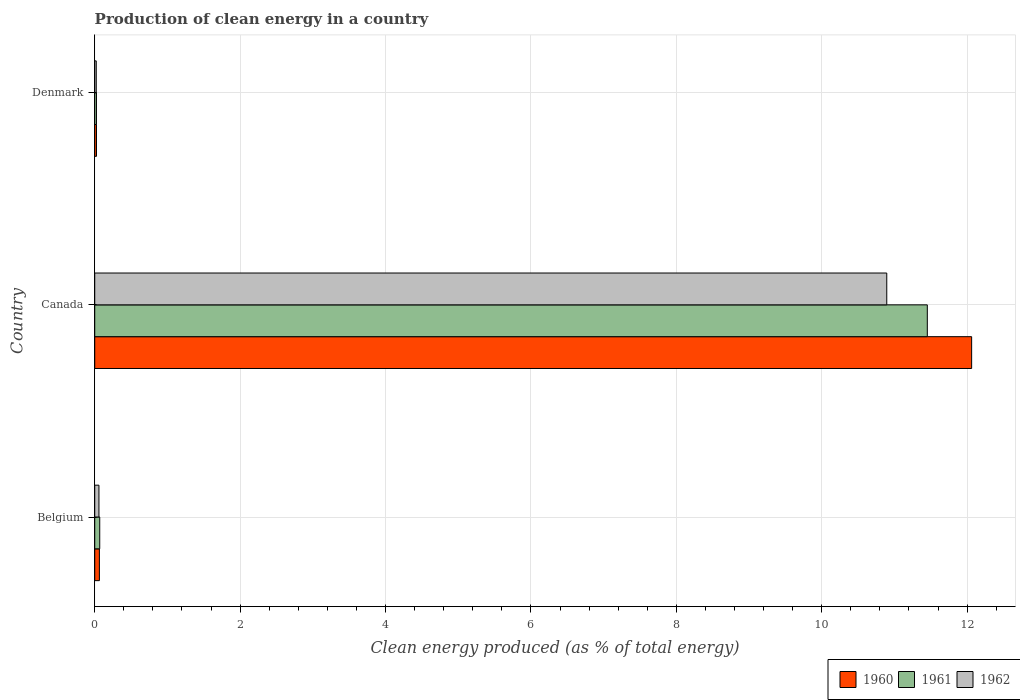Are the number of bars per tick equal to the number of legend labels?
Your response must be concise. Yes. What is the percentage of clean energy produced in 1961 in Belgium?
Your answer should be compact. 0.07. Across all countries, what is the maximum percentage of clean energy produced in 1962?
Make the answer very short. 10.89. Across all countries, what is the minimum percentage of clean energy produced in 1960?
Provide a short and direct response. 0.02. In which country was the percentage of clean energy produced in 1960 maximum?
Ensure brevity in your answer.  Canada. In which country was the percentage of clean energy produced in 1961 minimum?
Your answer should be very brief. Denmark. What is the total percentage of clean energy produced in 1961 in the graph?
Your answer should be very brief. 11.55. What is the difference between the percentage of clean energy produced in 1962 in Belgium and that in Denmark?
Provide a succinct answer. 0.04. What is the difference between the percentage of clean energy produced in 1961 in Denmark and the percentage of clean energy produced in 1960 in Belgium?
Offer a very short reply. -0.04. What is the average percentage of clean energy produced in 1960 per country?
Keep it short and to the point. 4.05. What is the difference between the percentage of clean energy produced in 1962 and percentage of clean energy produced in 1961 in Denmark?
Ensure brevity in your answer.  -0. In how many countries, is the percentage of clean energy produced in 1960 greater than 4.8 %?
Keep it short and to the point. 1. What is the ratio of the percentage of clean energy produced in 1962 in Belgium to that in Canada?
Give a very brief answer. 0.01. Is the percentage of clean energy produced in 1960 in Canada less than that in Denmark?
Make the answer very short. No. What is the difference between the highest and the second highest percentage of clean energy produced in 1962?
Provide a succinct answer. 10.84. What is the difference between the highest and the lowest percentage of clean energy produced in 1960?
Give a very brief answer. 12.04. What does the 1st bar from the bottom in Canada represents?
Provide a short and direct response. 1960. Is it the case that in every country, the sum of the percentage of clean energy produced in 1962 and percentage of clean energy produced in 1960 is greater than the percentage of clean energy produced in 1961?
Ensure brevity in your answer.  Yes. How many bars are there?
Provide a succinct answer. 9. Are all the bars in the graph horizontal?
Provide a succinct answer. Yes. How many countries are there in the graph?
Offer a terse response. 3. What is the difference between two consecutive major ticks on the X-axis?
Your response must be concise. 2. Are the values on the major ticks of X-axis written in scientific E-notation?
Make the answer very short. No. Does the graph contain any zero values?
Make the answer very short. No. Does the graph contain grids?
Provide a short and direct response. Yes. Where does the legend appear in the graph?
Give a very brief answer. Bottom right. What is the title of the graph?
Provide a short and direct response. Production of clean energy in a country. Does "1988" appear as one of the legend labels in the graph?
Your answer should be compact. No. What is the label or title of the X-axis?
Offer a terse response. Clean energy produced (as % of total energy). What is the label or title of the Y-axis?
Offer a terse response. Country. What is the Clean energy produced (as % of total energy) of 1960 in Belgium?
Provide a short and direct response. 0.06. What is the Clean energy produced (as % of total energy) of 1961 in Belgium?
Your response must be concise. 0.07. What is the Clean energy produced (as % of total energy) of 1962 in Belgium?
Keep it short and to the point. 0.06. What is the Clean energy produced (as % of total energy) in 1960 in Canada?
Ensure brevity in your answer.  12.06. What is the Clean energy produced (as % of total energy) in 1961 in Canada?
Offer a very short reply. 11.45. What is the Clean energy produced (as % of total energy) of 1962 in Canada?
Your answer should be very brief. 10.89. What is the Clean energy produced (as % of total energy) in 1960 in Denmark?
Give a very brief answer. 0.02. What is the Clean energy produced (as % of total energy) of 1961 in Denmark?
Make the answer very short. 0.02. What is the Clean energy produced (as % of total energy) in 1962 in Denmark?
Make the answer very short. 0.02. Across all countries, what is the maximum Clean energy produced (as % of total energy) of 1960?
Offer a very short reply. 12.06. Across all countries, what is the maximum Clean energy produced (as % of total energy) in 1961?
Offer a terse response. 11.45. Across all countries, what is the maximum Clean energy produced (as % of total energy) of 1962?
Provide a succinct answer. 10.89. Across all countries, what is the minimum Clean energy produced (as % of total energy) in 1960?
Your answer should be compact. 0.02. Across all countries, what is the minimum Clean energy produced (as % of total energy) of 1961?
Offer a very short reply. 0.02. Across all countries, what is the minimum Clean energy produced (as % of total energy) in 1962?
Your answer should be compact. 0.02. What is the total Clean energy produced (as % of total energy) in 1960 in the graph?
Offer a very short reply. 12.15. What is the total Clean energy produced (as % of total energy) in 1961 in the graph?
Offer a terse response. 11.55. What is the total Clean energy produced (as % of total energy) of 1962 in the graph?
Offer a very short reply. 10.97. What is the difference between the Clean energy produced (as % of total energy) in 1960 in Belgium and that in Canada?
Keep it short and to the point. -12. What is the difference between the Clean energy produced (as % of total energy) in 1961 in Belgium and that in Canada?
Provide a succinct answer. -11.38. What is the difference between the Clean energy produced (as % of total energy) in 1962 in Belgium and that in Canada?
Keep it short and to the point. -10.84. What is the difference between the Clean energy produced (as % of total energy) in 1960 in Belgium and that in Denmark?
Your answer should be compact. 0.04. What is the difference between the Clean energy produced (as % of total energy) of 1961 in Belgium and that in Denmark?
Keep it short and to the point. 0.04. What is the difference between the Clean energy produced (as % of total energy) of 1962 in Belgium and that in Denmark?
Provide a succinct answer. 0.04. What is the difference between the Clean energy produced (as % of total energy) in 1960 in Canada and that in Denmark?
Your answer should be compact. 12.04. What is the difference between the Clean energy produced (as % of total energy) in 1961 in Canada and that in Denmark?
Provide a succinct answer. 11.43. What is the difference between the Clean energy produced (as % of total energy) in 1962 in Canada and that in Denmark?
Ensure brevity in your answer.  10.87. What is the difference between the Clean energy produced (as % of total energy) of 1960 in Belgium and the Clean energy produced (as % of total energy) of 1961 in Canada?
Provide a succinct answer. -11.39. What is the difference between the Clean energy produced (as % of total energy) of 1960 in Belgium and the Clean energy produced (as % of total energy) of 1962 in Canada?
Make the answer very short. -10.83. What is the difference between the Clean energy produced (as % of total energy) of 1961 in Belgium and the Clean energy produced (as % of total energy) of 1962 in Canada?
Your response must be concise. -10.83. What is the difference between the Clean energy produced (as % of total energy) in 1960 in Belgium and the Clean energy produced (as % of total energy) in 1961 in Denmark?
Provide a succinct answer. 0.04. What is the difference between the Clean energy produced (as % of total energy) of 1960 in Belgium and the Clean energy produced (as % of total energy) of 1962 in Denmark?
Your answer should be very brief. 0.04. What is the difference between the Clean energy produced (as % of total energy) of 1961 in Belgium and the Clean energy produced (as % of total energy) of 1962 in Denmark?
Make the answer very short. 0.05. What is the difference between the Clean energy produced (as % of total energy) of 1960 in Canada and the Clean energy produced (as % of total energy) of 1961 in Denmark?
Make the answer very short. 12.04. What is the difference between the Clean energy produced (as % of total energy) in 1960 in Canada and the Clean energy produced (as % of total energy) in 1962 in Denmark?
Your answer should be very brief. 12.04. What is the difference between the Clean energy produced (as % of total energy) in 1961 in Canada and the Clean energy produced (as % of total energy) in 1962 in Denmark?
Your answer should be compact. 11.43. What is the average Clean energy produced (as % of total energy) in 1960 per country?
Ensure brevity in your answer.  4.05. What is the average Clean energy produced (as % of total energy) in 1961 per country?
Keep it short and to the point. 3.85. What is the average Clean energy produced (as % of total energy) of 1962 per country?
Give a very brief answer. 3.66. What is the difference between the Clean energy produced (as % of total energy) of 1960 and Clean energy produced (as % of total energy) of 1961 in Belgium?
Offer a terse response. -0. What is the difference between the Clean energy produced (as % of total energy) in 1960 and Clean energy produced (as % of total energy) in 1962 in Belgium?
Keep it short and to the point. 0.01. What is the difference between the Clean energy produced (as % of total energy) of 1961 and Clean energy produced (as % of total energy) of 1962 in Belgium?
Make the answer very short. 0.01. What is the difference between the Clean energy produced (as % of total energy) of 1960 and Clean energy produced (as % of total energy) of 1961 in Canada?
Your answer should be very brief. 0.61. What is the difference between the Clean energy produced (as % of total energy) in 1960 and Clean energy produced (as % of total energy) in 1962 in Canada?
Provide a succinct answer. 1.17. What is the difference between the Clean energy produced (as % of total energy) in 1961 and Clean energy produced (as % of total energy) in 1962 in Canada?
Keep it short and to the point. 0.56. What is the difference between the Clean energy produced (as % of total energy) in 1960 and Clean energy produced (as % of total energy) in 1962 in Denmark?
Keep it short and to the point. 0. What is the difference between the Clean energy produced (as % of total energy) of 1961 and Clean energy produced (as % of total energy) of 1962 in Denmark?
Your answer should be very brief. 0. What is the ratio of the Clean energy produced (as % of total energy) in 1960 in Belgium to that in Canada?
Your answer should be very brief. 0.01. What is the ratio of the Clean energy produced (as % of total energy) of 1961 in Belgium to that in Canada?
Give a very brief answer. 0.01. What is the ratio of the Clean energy produced (as % of total energy) in 1962 in Belgium to that in Canada?
Provide a short and direct response. 0.01. What is the ratio of the Clean energy produced (as % of total energy) in 1960 in Belgium to that in Denmark?
Provide a short and direct response. 2.63. What is the ratio of the Clean energy produced (as % of total energy) of 1961 in Belgium to that in Denmark?
Provide a short and direct response. 2.87. What is the ratio of the Clean energy produced (as % of total energy) in 1962 in Belgium to that in Denmark?
Your answer should be very brief. 2.77. What is the ratio of the Clean energy produced (as % of total energy) of 1960 in Canada to that in Denmark?
Your response must be concise. 494.07. What is the ratio of the Clean energy produced (as % of total energy) of 1961 in Canada to that in Denmark?
Provide a short and direct response. 477.92. What is the ratio of the Clean energy produced (as % of total energy) in 1962 in Canada to that in Denmark?
Make the answer very short. 520.01. What is the difference between the highest and the second highest Clean energy produced (as % of total energy) of 1960?
Give a very brief answer. 12. What is the difference between the highest and the second highest Clean energy produced (as % of total energy) in 1961?
Offer a terse response. 11.38. What is the difference between the highest and the second highest Clean energy produced (as % of total energy) of 1962?
Your answer should be very brief. 10.84. What is the difference between the highest and the lowest Clean energy produced (as % of total energy) in 1960?
Your answer should be compact. 12.04. What is the difference between the highest and the lowest Clean energy produced (as % of total energy) in 1961?
Offer a terse response. 11.43. What is the difference between the highest and the lowest Clean energy produced (as % of total energy) of 1962?
Provide a succinct answer. 10.87. 